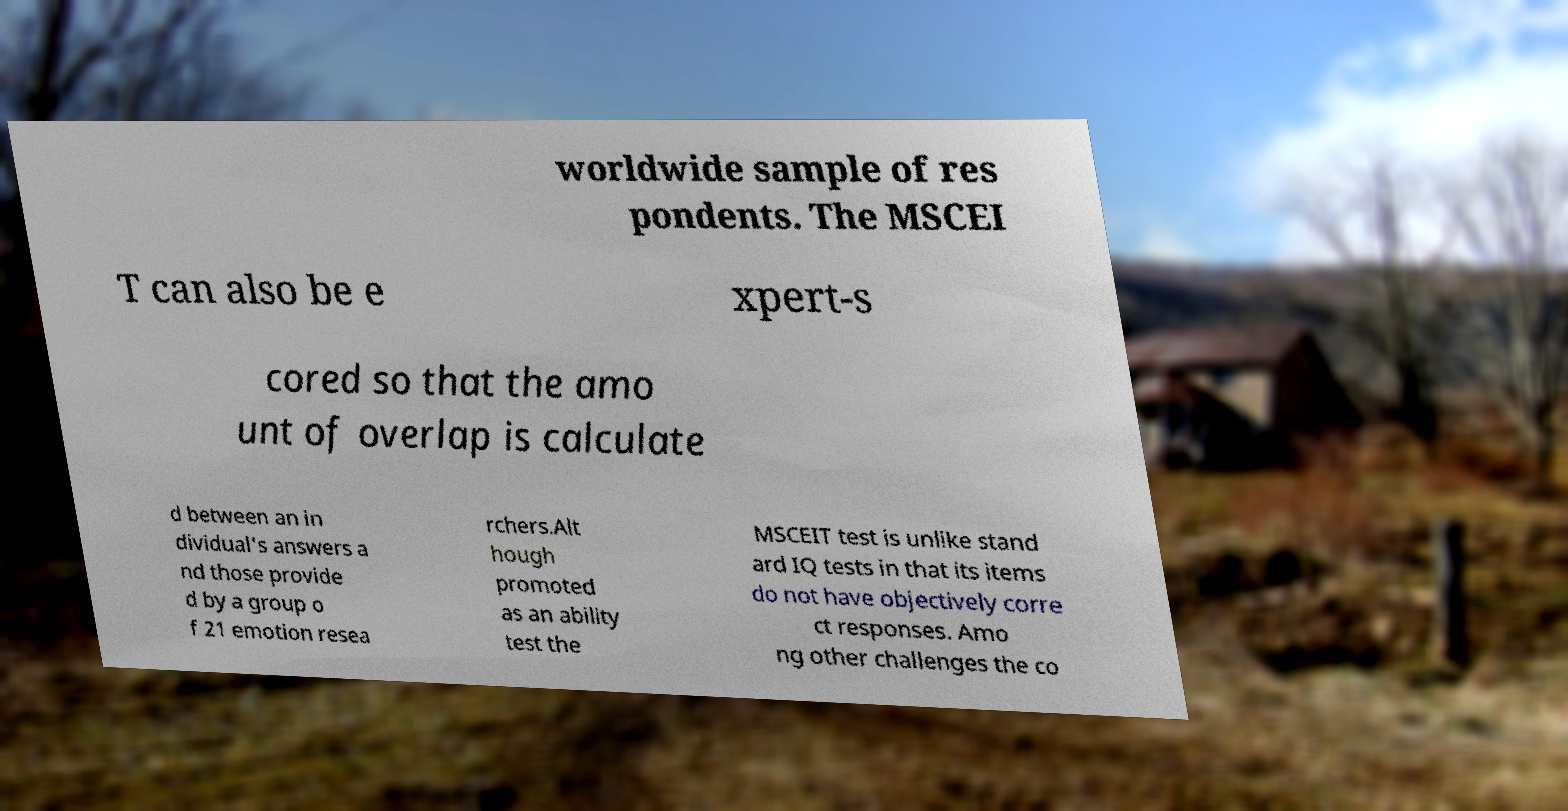Can you accurately transcribe the text from the provided image for me? worldwide sample of res pondents. The MSCEI T can also be e xpert-s cored so that the amo unt of overlap is calculate d between an in dividual's answers a nd those provide d by a group o f 21 emotion resea rchers.Alt hough promoted as an ability test the MSCEIT test is unlike stand ard IQ tests in that its items do not have objectively corre ct responses. Amo ng other challenges the co 